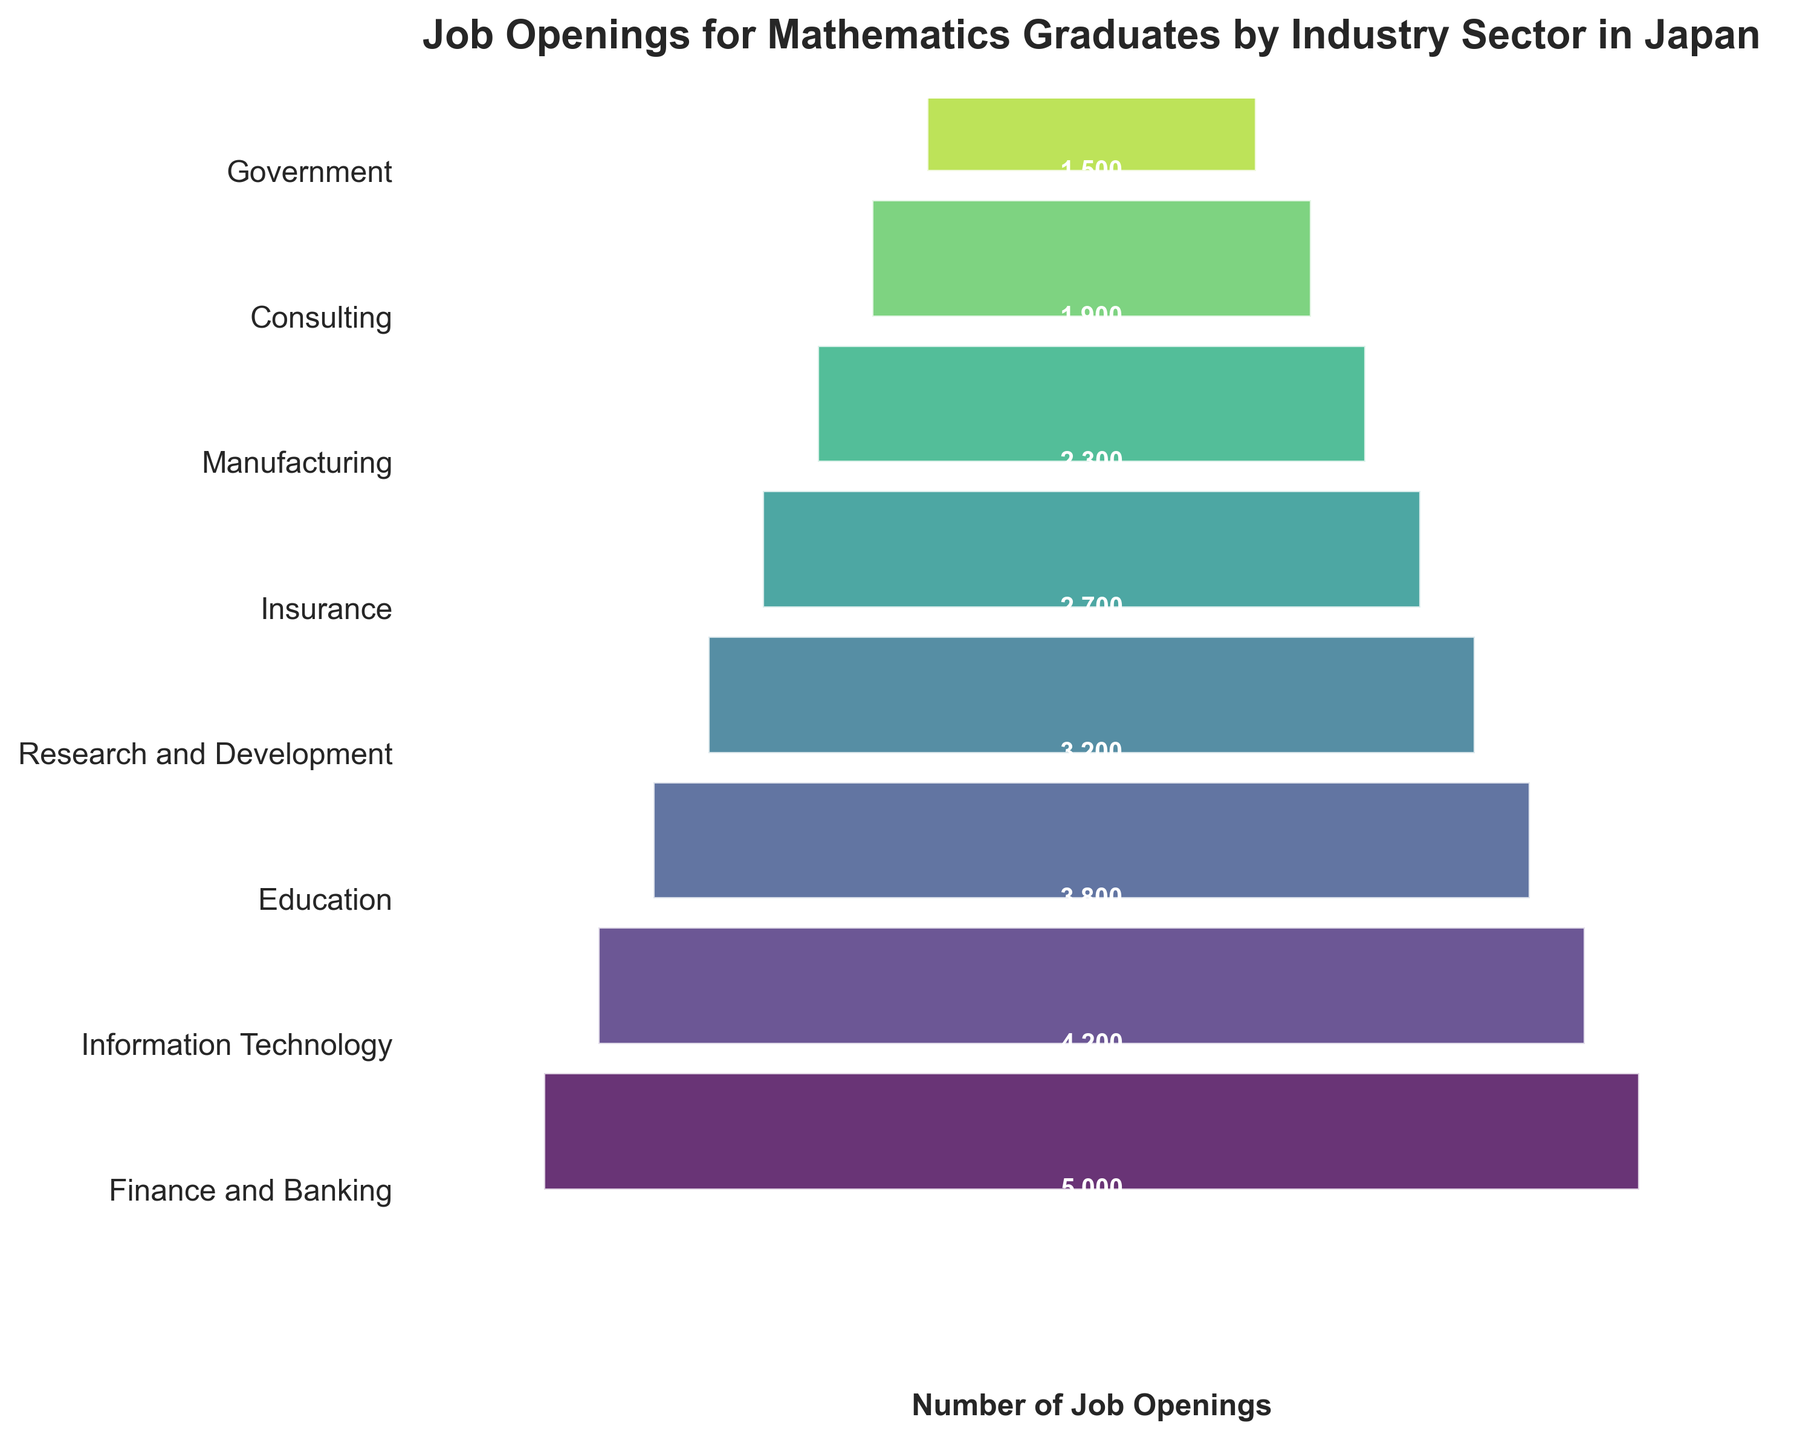What's the title of the plot? To find out the title, we look at the text displayed at the top of the figure.
Answer: Job Openings for Mathematics Graduates by Industry Sector in Japan Which industry sector has the highest number of job openings? We look at the widest section, which represents the largest number of job openings at the top of the funnel chart.
Answer: Finance and Banking What's the difference in job openings between the Finance and Banking sector and the Government sector? Subtract the number of job openings in the Government sector from that in the Finance and Banking sector: 5000 - 1500 = 3500.
Answer: 3500 Which industry has fewer job openings: Education or Manufacturing? Compare the widths of the sections labeled Education and Manufacturing. The narrower or shorter rectangle represents fewer job openings.
Answer: Manufacturing How many sectors have more than 3000 job openings? Identify the sectors with job openings greater than 3000 by counting them in the y-axis labels and corresponding rectangles.
Answer: 4 What's the total number of job openings across all sectors? Sum the number of job openings for all sectors: 5000 + 4200 + 3800 + 3200 + 2700 + 2300 + 1900 + 1500 = 27600.
Answer: 27600 Which sector is ranked third in terms of the number of job openings? Identify the third widest rectangle from the top.
Answer: Education What's the median number of job openings across all industry sectors? To find the median, list all job openings in ascending order and find the middle value: (1500, 1900, 2300, 2700, 3200, 3800, 4200, 5000). The median is the average of 2700 and 3200: (2700 + 3200)/2 = 2950.
Answer: 2950 Which sector appears directly above the Government sector in terms of job openings? Find the sector just above the narrowest section.
Answer: Consulting 